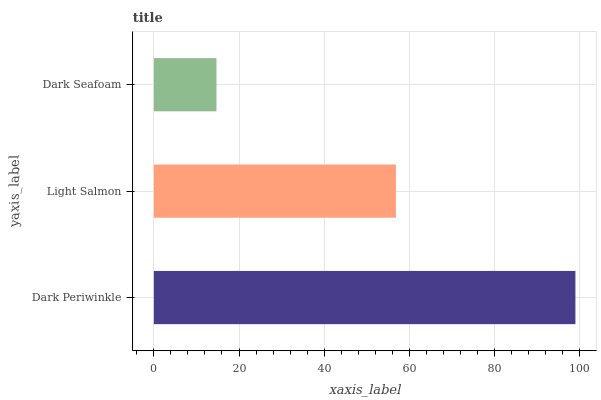Is Dark Seafoam the minimum?
Answer yes or no. Yes. Is Dark Periwinkle the maximum?
Answer yes or no. Yes. Is Light Salmon the minimum?
Answer yes or no. No. Is Light Salmon the maximum?
Answer yes or no. No. Is Dark Periwinkle greater than Light Salmon?
Answer yes or no. Yes. Is Light Salmon less than Dark Periwinkle?
Answer yes or no. Yes. Is Light Salmon greater than Dark Periwinkle?
Answer yes or no. No. Is Dark Periwinkle less than Light Salmon?
Answer yes or no. No. Is Light Salmon the high median?
Answer yes or no. Yes. Is Light Salmon the low median?
Answer yes or no. Yes. Is Dark Seafoam the high median?
Answer yes or no. No. Is Dark Seafoam the low median?
Answer yes or no. No. 